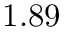Convert formula to latex. <formula><loc_0><loc_0><loc_500><loc_500>1 . 8 9</formula> 